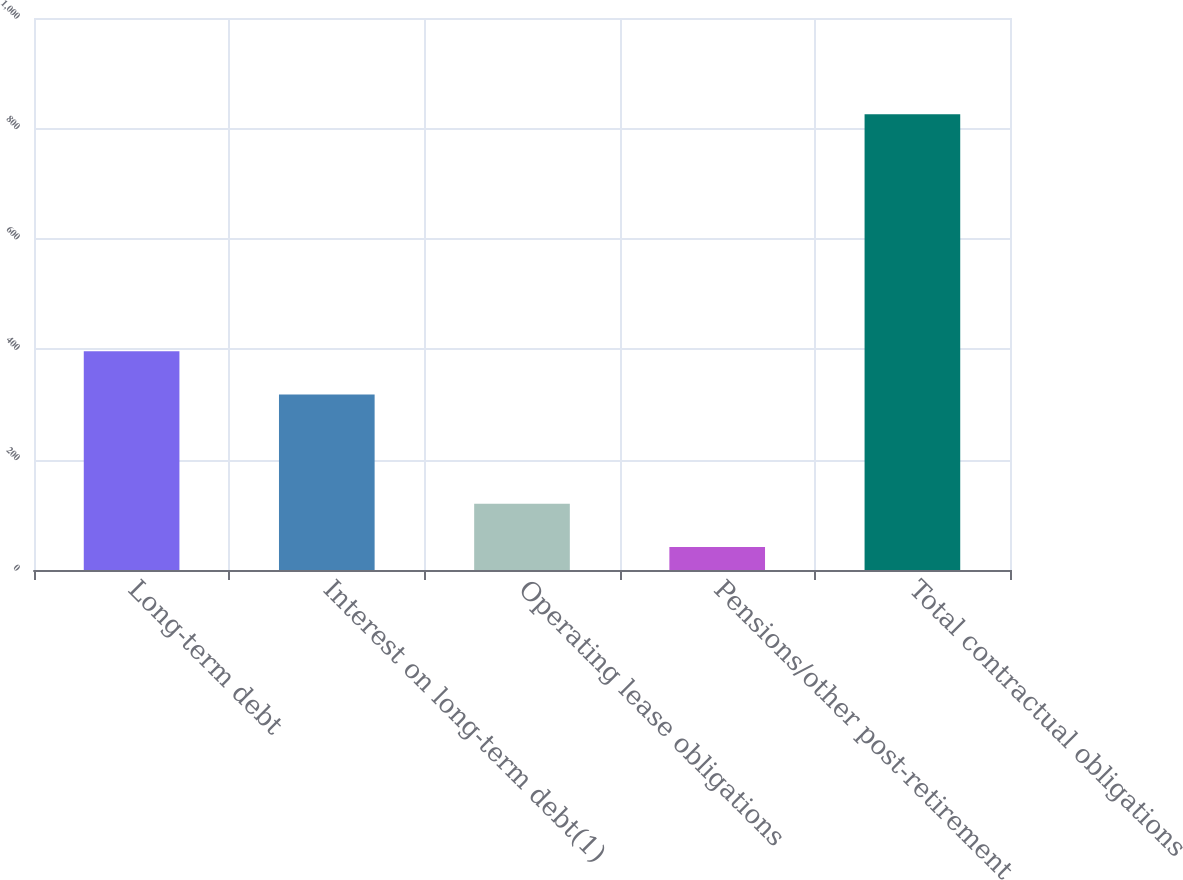Convert chart. <chart><loc_0><loc_0><loc_500><loc_500><bar_chart><fcel>Long-term debt<fcel>Interest on long-term debt(1)<fcel>Operating lease obligations<fcel>Pensions/other post-retirement<fcel>Total contractual obligations<nl><fcel>396.48<fcel>318.1<fcel>120.18<fcel>41.8<fcel>825.6<nl></chart> 